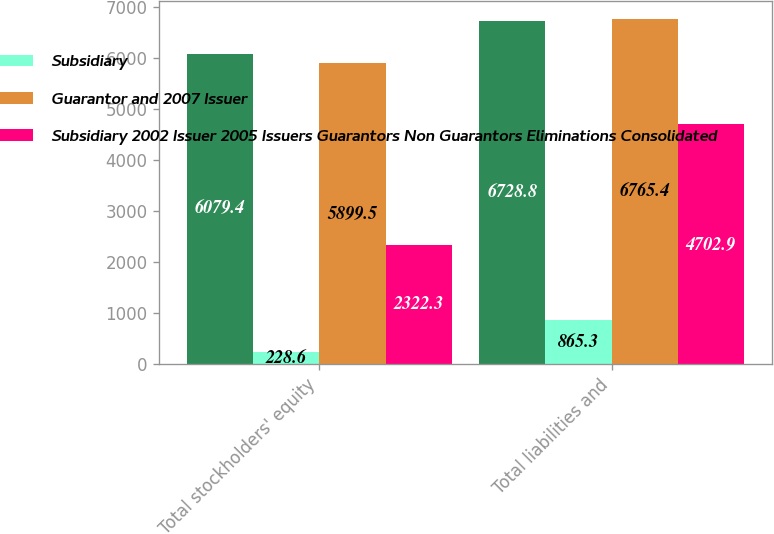Convert chart to OTSL. <chart><loc_0><loc_0><loc_500><loc_500><stacked_bar_chart><ecel><fcel>Total stockholders' equity<fcel>Total liabilities and<nl><fcel>nan<fcel>6079.4<fcel>6728.8<nl><fcel>Subsidiary<fcel>228.6<fcel>865.3<nl><fcel>Guarantor and 2007 Issuer<fcel>5899.5<fcel>6765.4<nl><fcel>Subsidiary 2002 Issuer 2005 Issuers Guarantors Non Guarantors Eliminations Consolidated<fcel>2322.3<fcel>4702.9<nl></chart> 